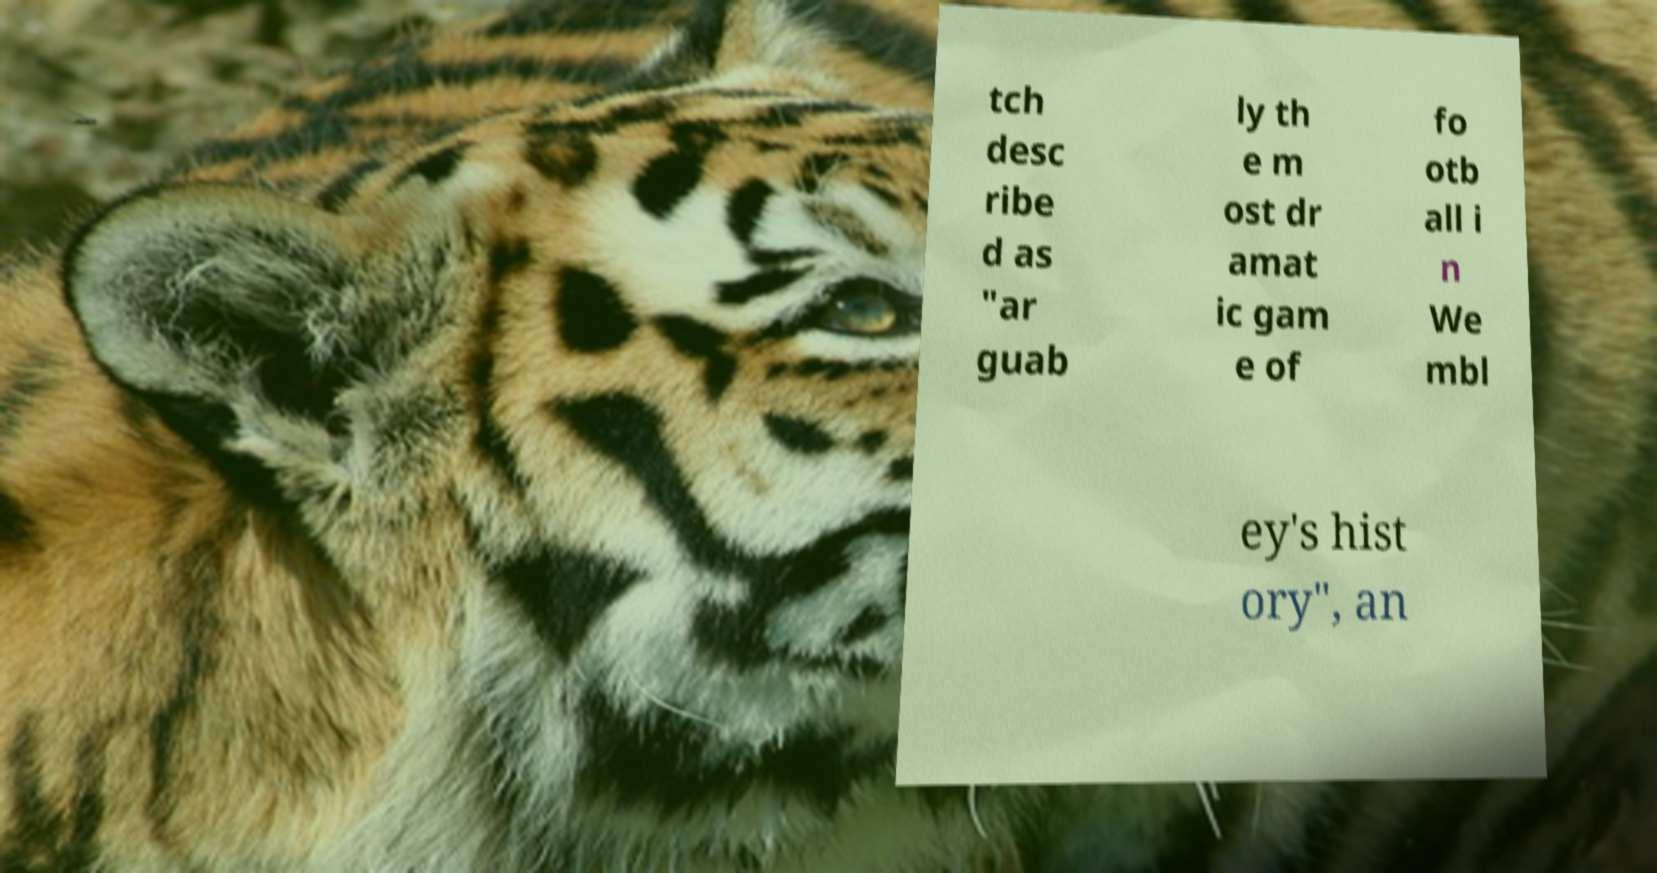Please identify and transcribe the text found in this image. tch desc ribe d as "ar guab ly th e m ost dr amat ic gam e of fo otb all i n We mbl ey's hist ory", an 